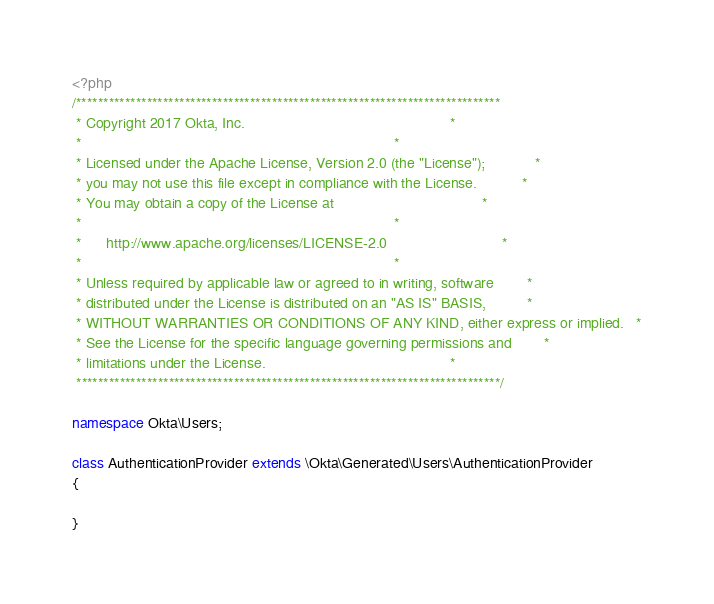Convert code to text. <code><loc_0><loc_0><loc_500><loc_500><_PHP_><?php
/******************************************************************************
 * Copyright 2017 Okta, Inc.                                                  *
 *                                                                            *
 * Licensed under the Apache License, Version 2.0 (the "License");            *
 * you may not use this file except in compliance with the License.           *
 * You may obtain a copy of the License at                                    *
 *                                                                            *
 *      http://www.apache.org/licenses/LICENSE-2.0                            *
 *                                                                            *
 * Unless required by applicable law or agreed to in writing, software        *
 * distributed under the License is distributed on an "AS IS" BASIS,          *
 * WITHOUT WARRANTIES OR CONDITIONS OF ANY KIND, either express or implied.   *
 * See the License for the specific language governing permissions and        *
 * limitations under the License.                                             *
 ******************************************************************************/

namespace Okta\Users;

class AuthenticationProvider extends \Okta\Generated\Users\AuthenticationProvider
{

}
</code> 